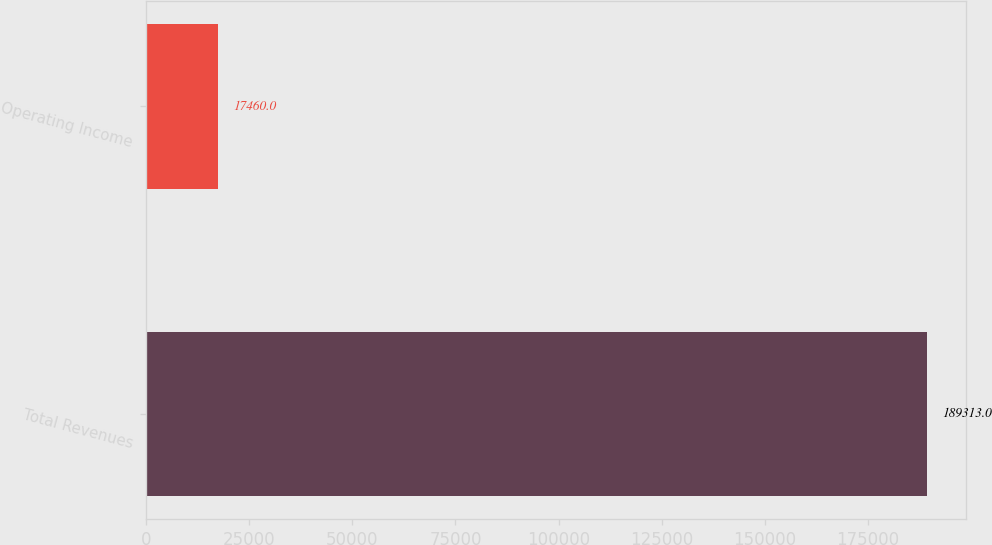Convert chart. <chart><loc_0><loc_0><loc_500><loc_500><bar_chart><fcel>Total Revenues<fcel>Operating Income<nl><fcel>189313<fcel>17460<nl></chart> 